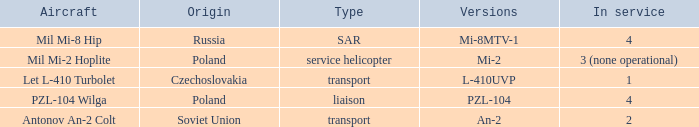Tell me the versions for czechoslovakia? L-410UVP. 